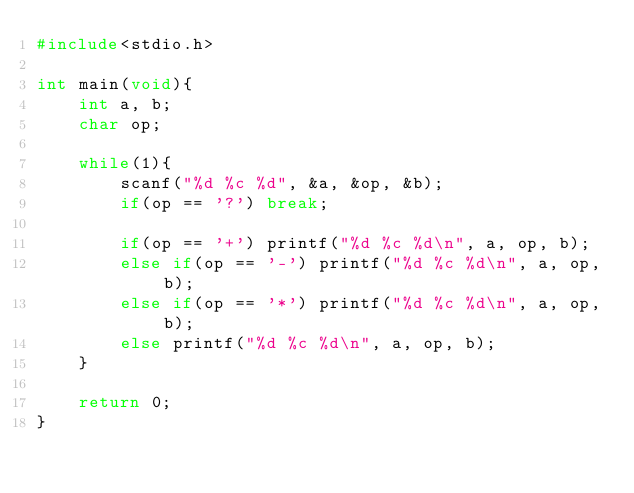Convert code to text. <code><loc_0><loc_0><loc_500><loc_500><_C_>#include<stdio.h>

int main(void){
    int a, b;
    char op;

    while(1){
        scanf("%d %c %d", &a, &op, &b);
        if(op == '?') break;

        if(op == '+') printf("%d %c %d\n", a, op, b);
        else if(op == '-') printf("%d %c %d\n", a, op, b);
        else if(op == '*') printf("%d %c %d\n", a, op, b);
        else printf("%d %c %d\n", a, op, b);
    }

    return 0;
}</code> 